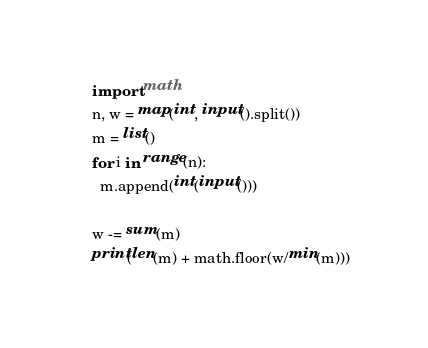<code> <loc_0><loc_0><loc_500><loc_500><_Python_>import math
n, w = map(int, input().split())
m = list()
for i in range(n):
  m.append(int(input()))

w -= sum(m)
print(len(m) + math.floor(w/min(m)))</code> 